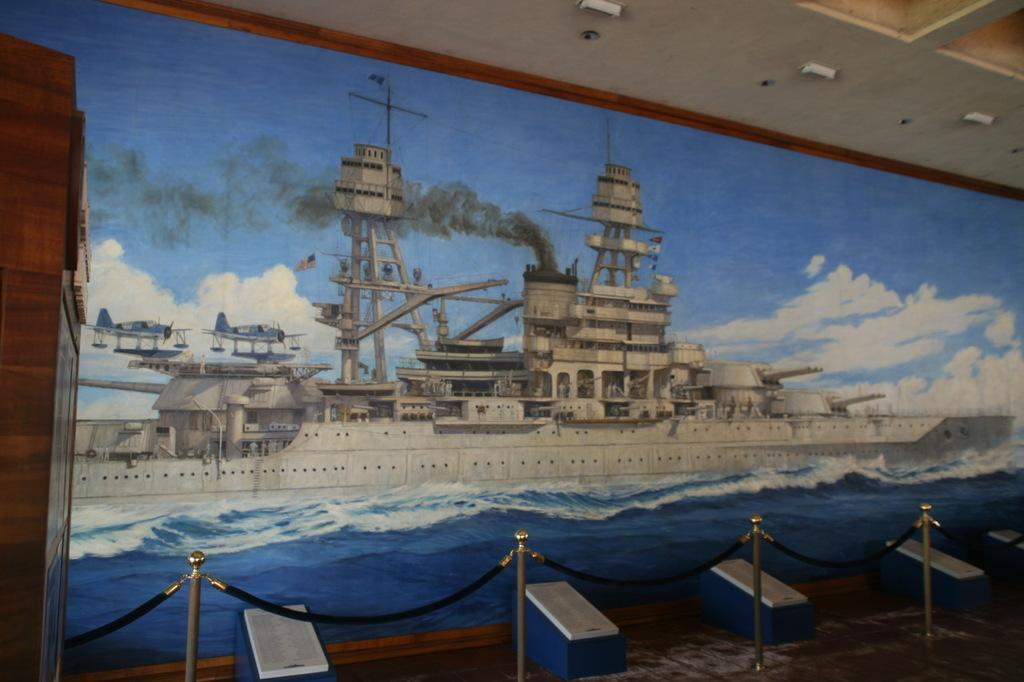What type of barrier is present in the image? There is a rope fence in the image. What can be found inside the large photo frame? The photo frame contains an image of a ship on water. Where is the cabinet located in the image? The cabinet is on the left side of the image. What type of government is depicted in the image of the ship? There is no depiction of a government in the image; it features a photo of a ship on water. Is there a camera visible in the image? There is no camera present in the image. 